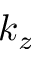<formula> <loc_0><loc_0><loc_500><loc_500>k _ { z }</formula> 